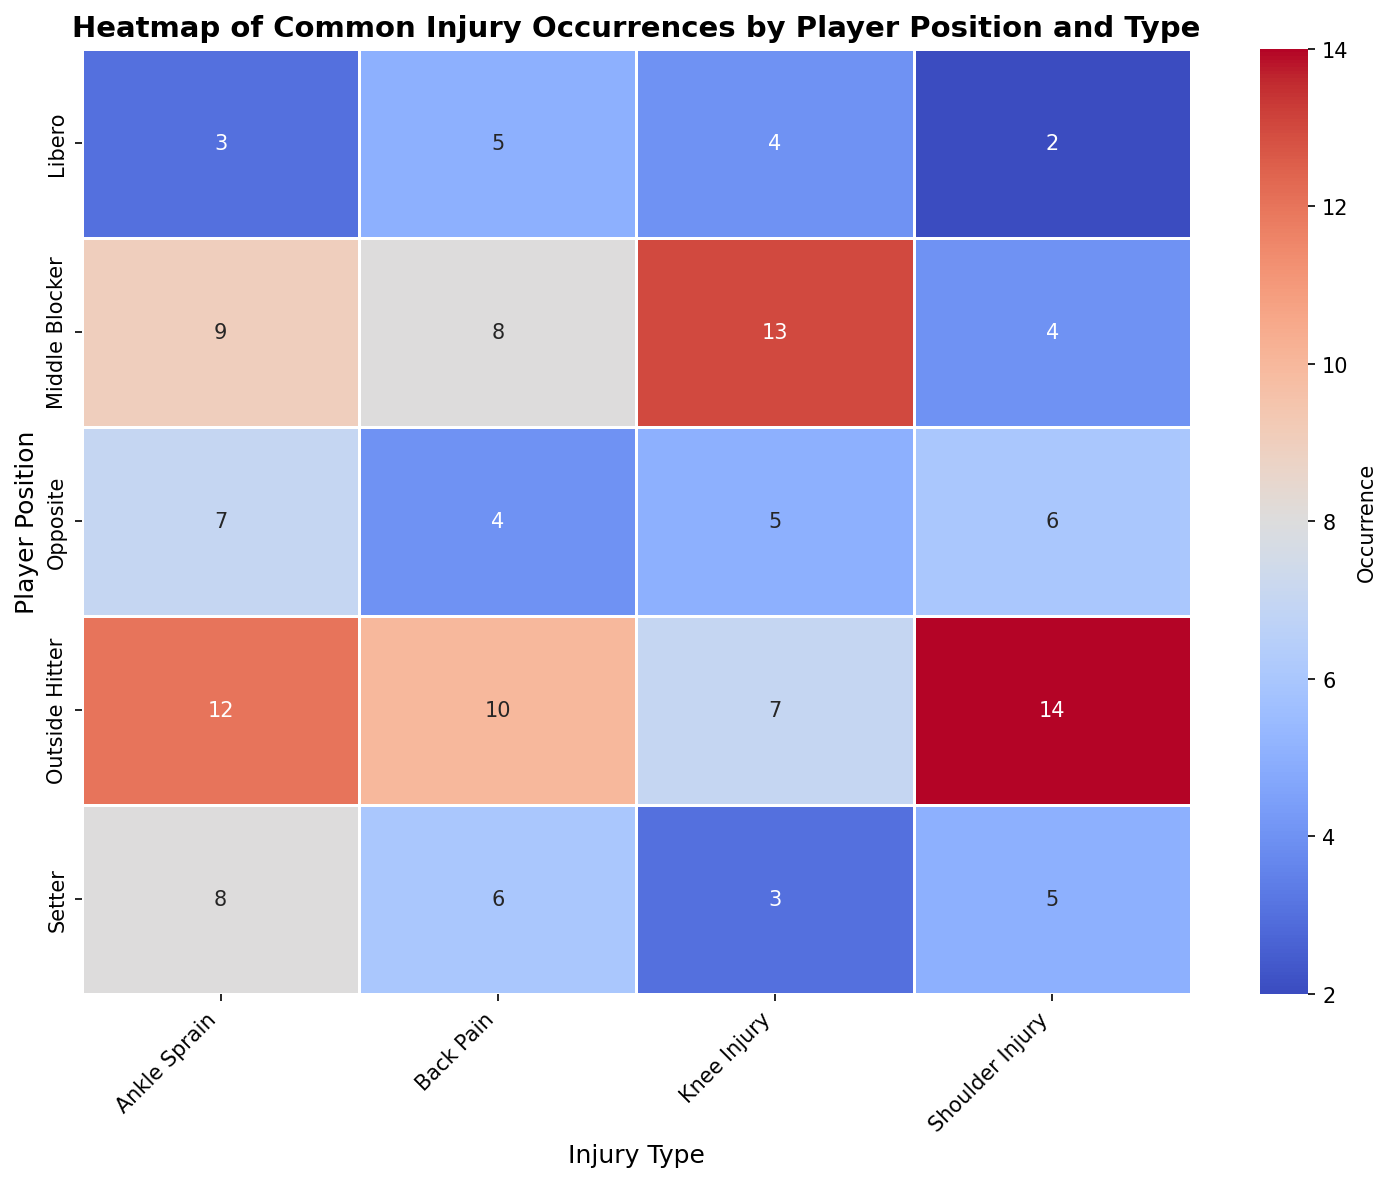Which position has the highest occurrence of Shoulder Injuries? By observing the heatmap, identify the cell corresponding to Shoulder Injuries and look for the highest value among the player positions. The Outside Hitter has the highest occurrence with a value of 14.
Answer: Outside Hitter How many total Ankle Sprains occurred across all positions? Sum the values in the Ankle Sprain column: Setter (8) + Outside Hitter (12) + Middle Blocker (9) + Libero (3) + Opposite (7). Calculating gives 8 + 12 + 9 + 3 + 7 = 39.
Answer: 39 Which injury type appears to be most common for Setters? Compare the values in the Setter row for each injury type. The highest value is for Ankle Sprains with a count of 8.
Answer: Ankle Sprain Which player position has the least occurrences of Back Pain? Identify the cells in the Back Pain column and look for the lowest value. The Libero has the least occurrences with a value of 5.
Answer: Libero Is there a player position that has fewer than 5 occurrences of any injury type? Check each row for values less than 5. The Libero has 3 Ankell Sprains, 2 Shoulder Injuries, and 4 Knee Injuries, and Opposite has 4 Back Pains.
Answer: Yes What is the difference in the number of Knee Injuries between Middle Blockers and Liberos? Find the values for Middle Blockers and Liberos in the Knee Injury column and compute the difference: 13 (Middle Blocker) - 4 (Libero) = 9.
Answer: 9 Which injury type is more common for Opposites: Ankle Sprain or Shoulder Injury? Compare the values for Opposites in the Ankle Sprain and Shoulder Injury columns. Ankle Sprain has 7 occurrences while Shoulder Injury has 6 occurrences, so Ankle Sprain is more common.
Answer: Ankle Sprain How many Orthopedic injuries are reported for Outside Hitters? (Assume Shoulder Injuries and Knee Injuries are orthopedic injuries) Sum the occurrences for Shoulder Injuries and Knee Injuries for Outside Hitters: 14 (Shoulder Injuries) + 7 (Knee Injuries) = 21.
Answer: 21 What is the average number of Back Pain occurrences across all positions? Sum the values in the Back Pain column and divide by the number of player positions: (6+10+8+5+4)/5. Calculating gives (33)/5 = 6.6.
Answer: 6.6 